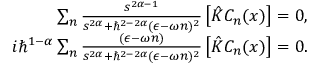Convert formula to latex. <formula><loc_0><loc_0><loc_500><loc_500>\begin{array} { r } { \sum _ { n } \frac { s ^ { 2 \alpha - 1 } } { s ^ { 2 \alpha } + \hbar { ^ } { 2 - 2 \alpha } ( \epsilon - \omega n ) ^ { 2 } } \left [ \hat { K } C _ { n } ( x ) \right ] = 0 , } \\ { i \hbar { ^ } { 1 - \alpha } \sum _ { n } \frac { ( \epsilon - \omega n ) } { s ^ { 2 \alpha } + \hbar { ^ } { 2 - 2 \alpha } ( \epsilon - \omega n ) ^ { 2 } } \left [ \hat { K } C _ { n } ( x ) \right ] = 0 . } \end{array}</formula> 